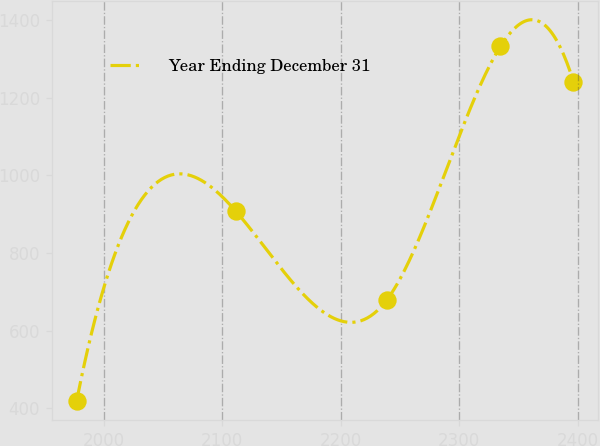<chart> <loc_0><loc_0><loc_500><loc_500><line_chart><ecel><fcel>Year Ending December 31<nl><fcel>1976.98<fcel>418.46<nl><fcel>2111.53<fcel>907.3<nl><fcel>2238.91<fcel>679.43<nl><fcel>2334.74<fcel>1332.76<nl><fcel>2396.39<fcel>1241.88<nl></chart> 